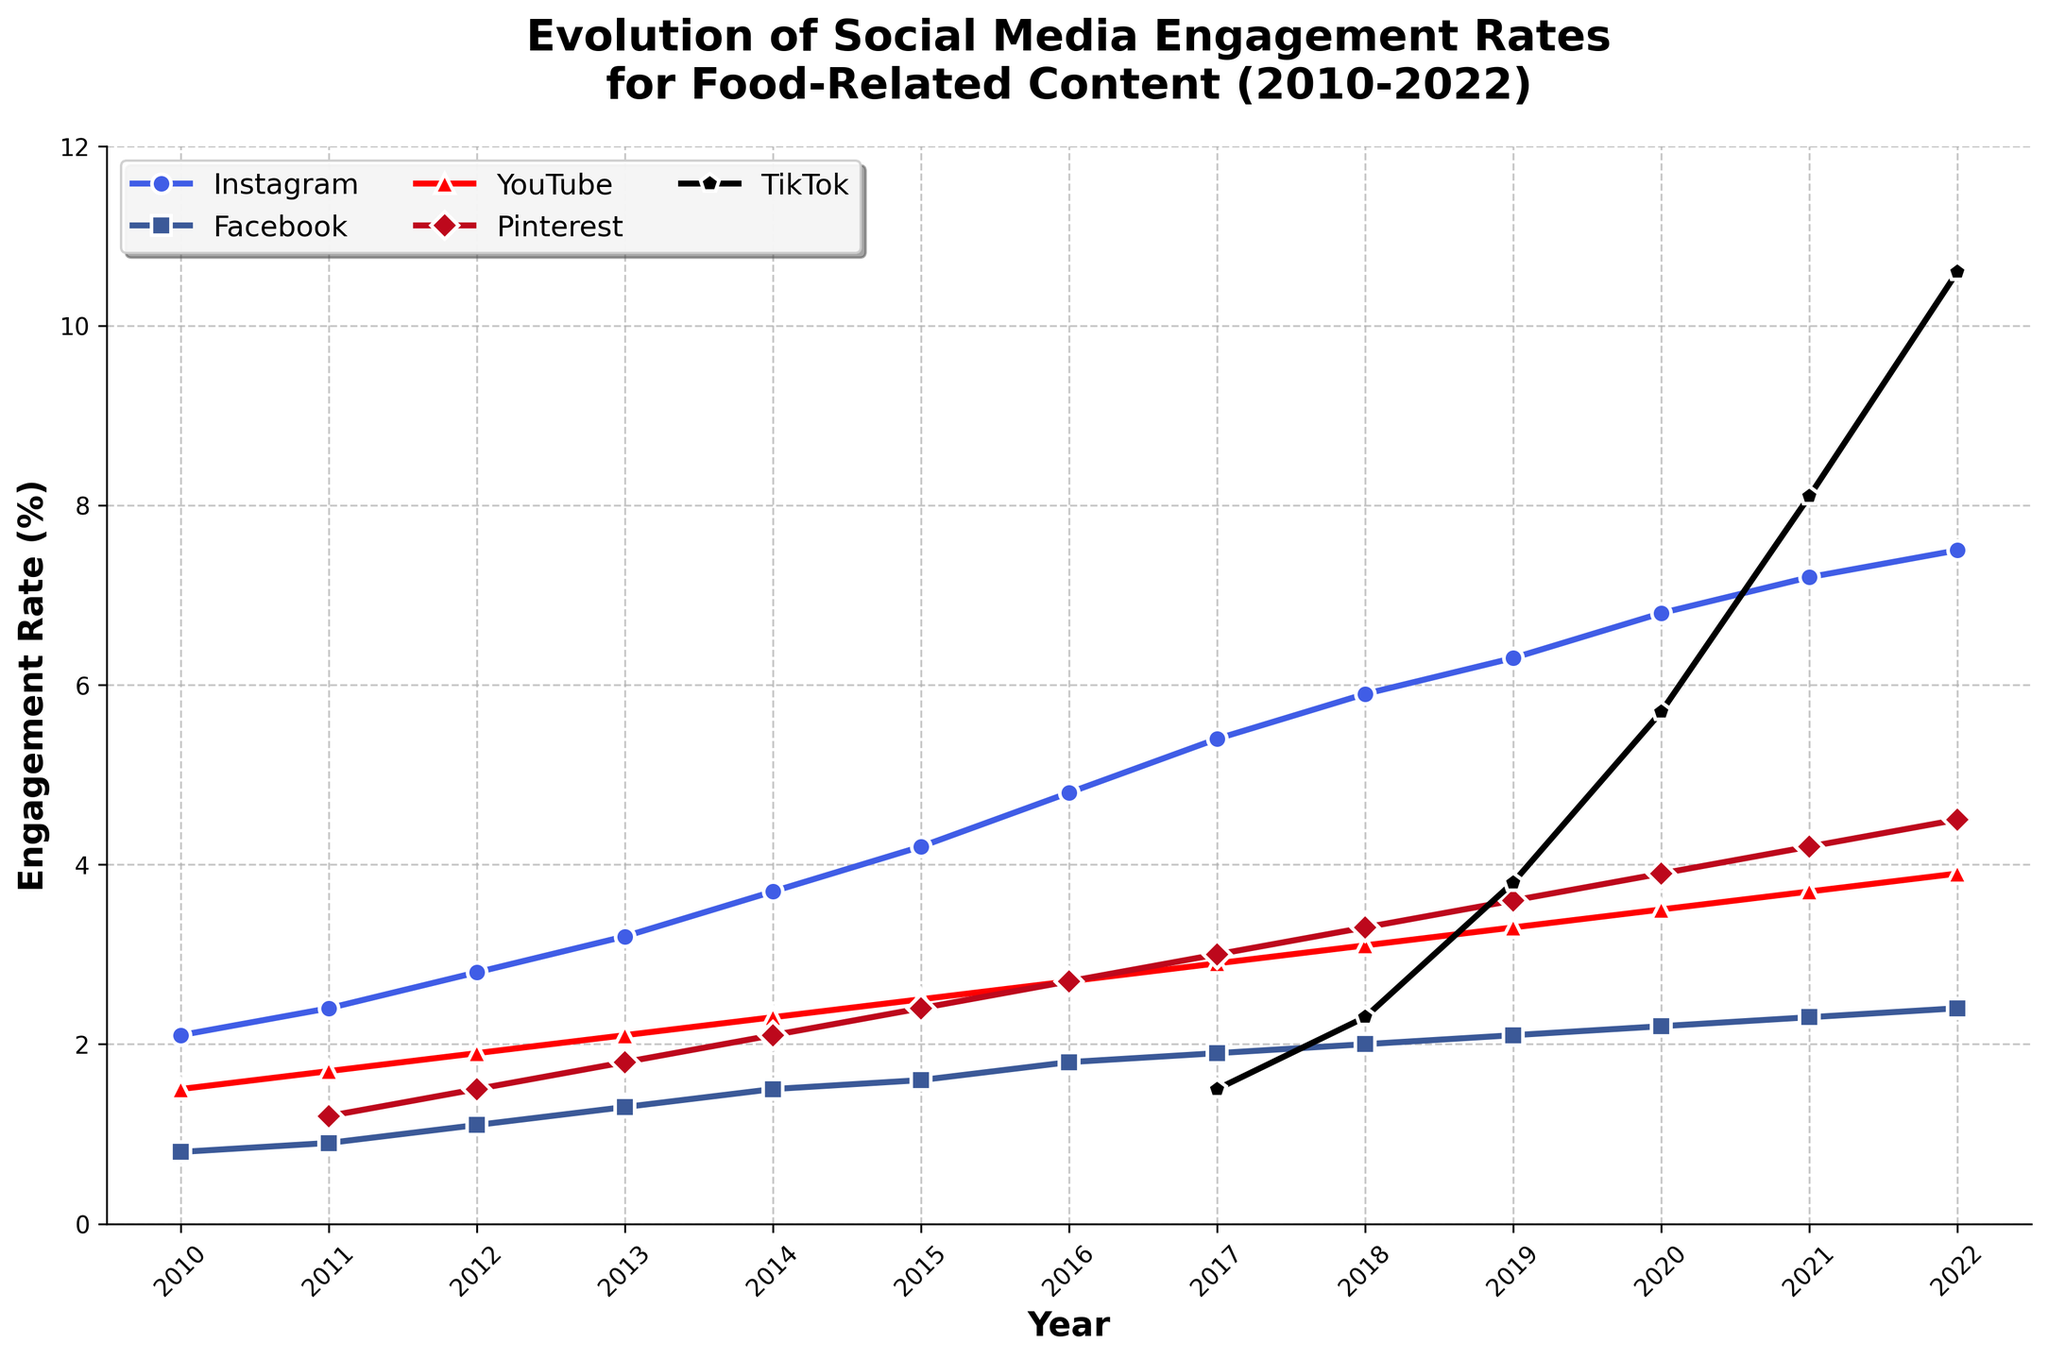What's the highest engagement rate for Instagram? By examining the top point of the Instagram line in the chart, we notice that the peak occurs in 2022 with an engagement rate of 7.5%.
Answer: 7.5% Which platform showed the most significant growth in engagement rate from 2017 to 2022? To determine this, we examine the slopes of the lines from 2017 to 2022 for each platform. TikTok shows the steepest rise, from 1.5% to 10.6%.
Answer: TikTok What was the engagement rate for Facebook in 2015, and how did it change by 2020? The engagement rate for Facebook in 2015 is 1.6%. By 2020, it increased slightly to 2.2%. The change is 2.2% - 1.6% = 0.6%.
Answer: Increased by 0.6% During which year did TikTok first cross the 5% engagement rate mark? Observing the TikTok line, the engagement rate first exceeds 5% in 2020, with a value of 5.7%.
Answer: 2020 Between Instagram and Pinterest, which platform had a higher engagement rate in 2013 and by how much? In 2013, Instagram's engagement rate is 3.2%, while Pinterest's rate is 1.8%. The difference is 3.2% - 1.8% = 1.4%.
Answer: Instagram by 1.4% What trend do you observe in Pinterest engagement rates from 2010 to 2022? Each point on the Pinterest line from 2010 to 2022 shows a steady increase each year, indicating a consistent upward trend.
Answer: Steady increase How did YouTube's engagement rate change from 2010 to 2022? YouTube started at 1.5% in 2010 and rose to 3.9% in 2022. This shows a gradual but consistent increase over the years.
Answer: Gradual increase Which platform had the lowest engagement rate in 2022 and what was the value? By comparing the end points of all lines in 2022, Facebook has the lowest engagement rate of 2.4%.
Answer: Facebook, 2.4% What was the difference in engagement rates between YouTube and Pinterest in 2020? The engagement rate for YouTube in 2020 is 3.5%, and for Pinterest, it’s 3.9%. The difference is 3.9% - 3.5% = 0.4%.
Answer: 0.4% From 2017 to 2022, which platform saw the least increase in the engagement rate? By examining the differences between 2017 and 2022 for all platforms, Facebook shows the least increase from 1.9% to 2.4%, a difference of 0.5%.
Answer: Facebook 